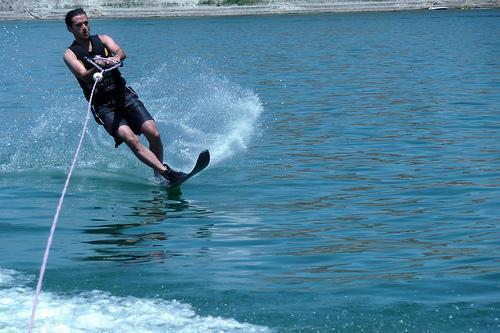How many people are water skiing?
Give a very brief answer. 1. How many people are eating donuts?
Give a very brief answer. 0. How many elephants are pictured?
Give a very brief answer. 0. 